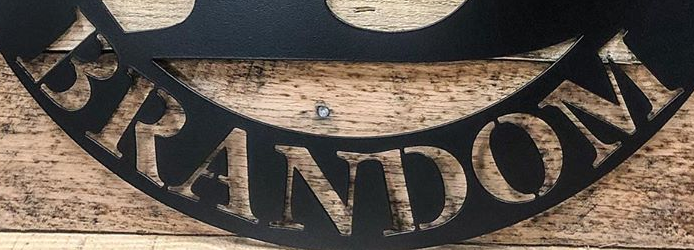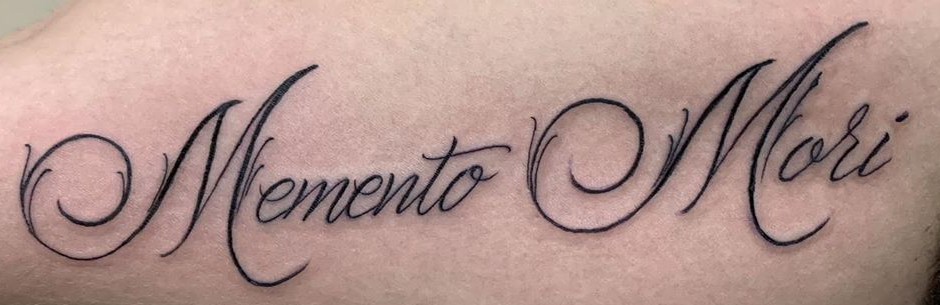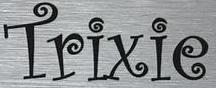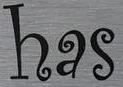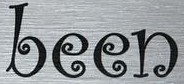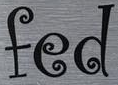What text appears in these images from left to right, separated by a semicolon? BRANDOM; MementoMori; Trixie; has; been; fed 